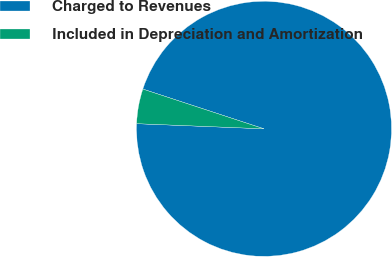Convert chart to OTSL. <chart><loc_0><loc_0><loc_500><loc_500><pie_chart><fcel>Charged to Revenues<fcel>Included in Depreciation and Amortization<nl><fcel>95.6%<fcel>4.4%<nl></chart> 